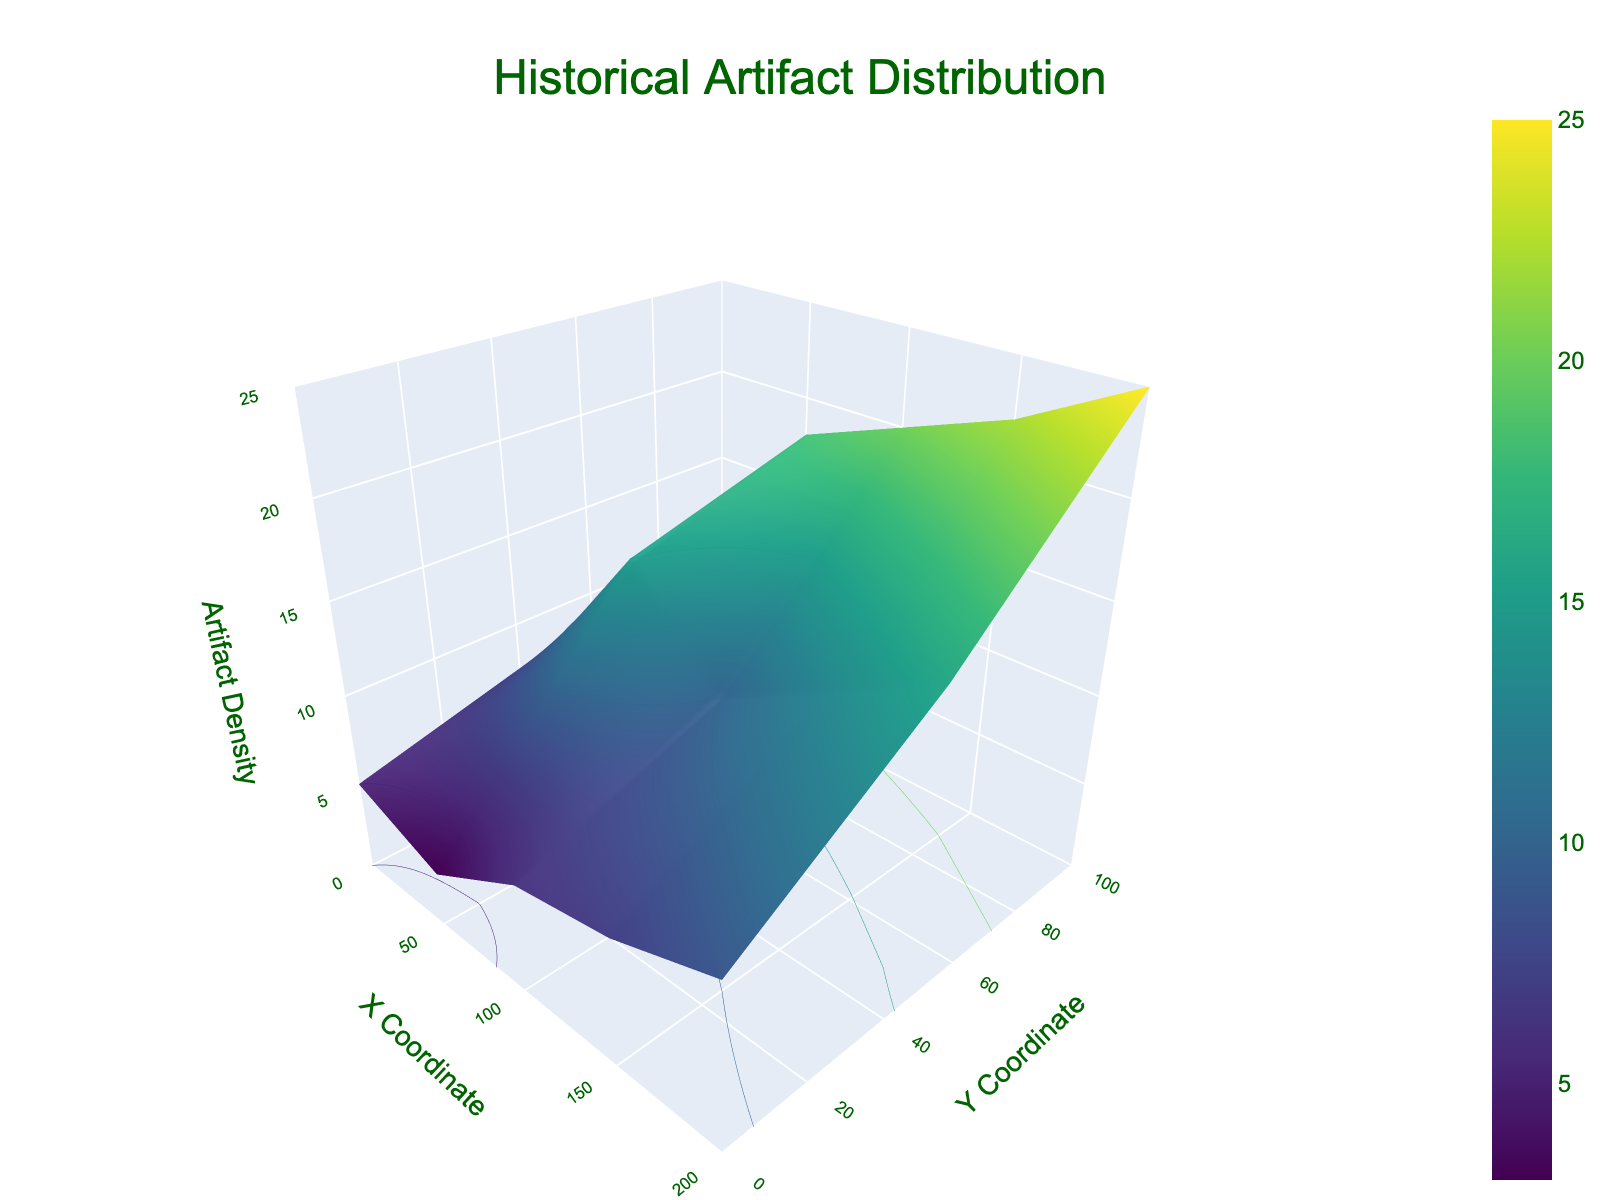What is the title of the figure? The title is centered at the top of the figure. It reads "Historical Artifact Distribution". This can be directly observed from the visual representation.
Answer: Historical Artifact Distribution What do the X and Y axes represent? The X and Y axes represent geographical coordinates on the property. The X-axis is labeled "X Coordinate" and the Y-axis is labeled "Y Coordinate". This information can be read from the axis labels.
Answer: Geographical coordinates What is the range of Artifact Density values shown on the Z-axis? The Z-axis is labeled "Artifact Density" and ranges from 0 to 25 as indicated on the axis ticks. This range is visible on the Z-axis itself.
Answer: 0 to 25 Where is the maximum artifact density found in terms of X and Y coordinates? By looking at the highest point on the Z-axis (Artifact Density), we observe it occurs at (200, 100) where the artifact density reaches its peak. This observation is made by locating the highest surface peak.
Answer: (200, 100) Is the artifact density higher at (100, 100) or (150, 50)? By comparing the Z-axis values at these two points, (100, 100) has a density of 20, while (150, 50) has a density of 13. Thus, the artifact density is higher at (100, 100).
Answer: (100, 100) What is the average artifact density for the coordinates (0,0), (50,0), and (100,0)? The artifact densities for these points are 5, 3, and 6 respectively. The average is calculated by (5 + 3 + 6)/3 = 4.67. Thus, the average artifact density is approximately 4.67.
Answer: 4.67 Which area shows a greater depth, (0, 50) or (50, 50)? According to the data provided, (0, 50) has a depth of 15, while (50, 50) has a depth of 25. Therefore, (50, 50) shows a greater depth.
Answer: (50, 50) Do artifact densities generally increase or decrease with depth? Observing the 3D surface plot, it appears that artifact density tends to increase with depth. This is inferred by looking at how deeper regions generally correspond to higher densities in the plot.
Answer: Increase What is the trend of artifact density from (0,0) to (200,100)? Monitoring the artifact density from (0,0) to (200,100), we see a general increasing trend as the artifact density rises from 5 to 25. This is visible through the ascending color gradient and surface.
Answer: Increasing What is the artifact density at the coordinates (150, 100)? According to the data, the artifact density at the coordinates (150, 100) is 22. This value can be cross-referenced directly from the figure at those coordinates.
Answer: 22 